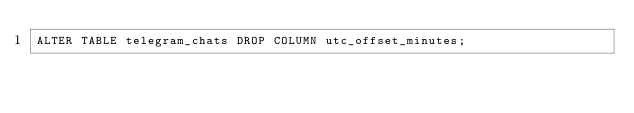<code> <loc_0><loc_0><loc_500><loc_500><_SQL_>ALTER TABLE telegram_chats DROP COLUMN utc_offset_minutes;
</code> 